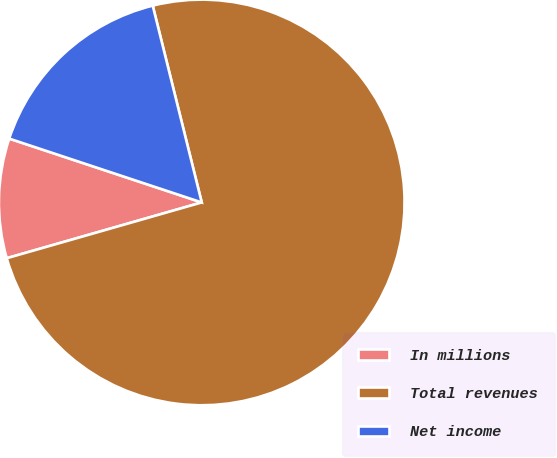Convert chart to OTSL. <chart><loc_0><loc_0><loc_500><loc_500><pie_chart><fcel>In millions<fcel>Total revenues<fcel>Net income<nl><fcel>9.53%<fcel>74.45%<fcel>16.02%<nl></chart> 